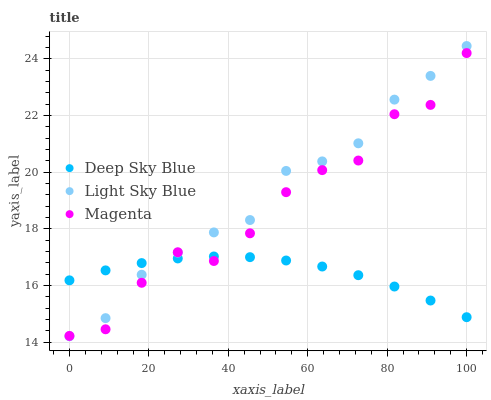Does Deep Sky Blue have the minimum area under the curve?
Answer yes or no. Yes. Does Light Sky Blue have the maximum area under the curve?
Answer yes or no. Yes. Does Light Sky Blue have the minimum area under the curve?
Answer yes or no. No. Does Deep Sky Blue have the maximum area under the curve?
Answer yes or no. No. Is Deep Sky Blue the smoothest?
Answer yes or no. Yes. Is Magenta the roughest?
Answer yes or no. Yes. Is Light Sky Blue the smoothest?
Answer yes or no. No. Is Light Sky Blue the roughest?
Answer yes or no. No. Does Light Sky Blue have the lowest value?
Answer yes or no. Yes. Does Deep Sky Blue have the lowest value?
Answer yes or no. No. Does Light Sky Blue have the highest value?
Answer yes or no. Yes. Does Deep Sky Blue have the highest value?
Answer yes or no. No. Does Magenta intersect Light Sky Blue?
Answer yes or no. Yes. Is Magenta less than Light Sky Blue?
Answer yes or no. No. Is Magenta greater than Light Sky Blue?
Answer yes or no. No. 